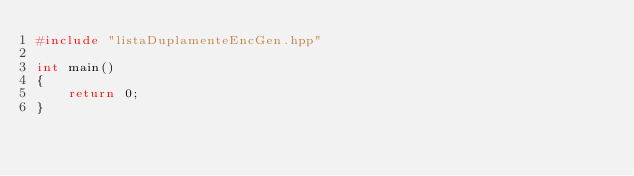Convert code to text. <code><loc_0><loc_0><loc_500><loc_500><_C++_>#include "listaDuplamenteEncGen.hpp"

int main()
{
    return 0;
}

</code> 